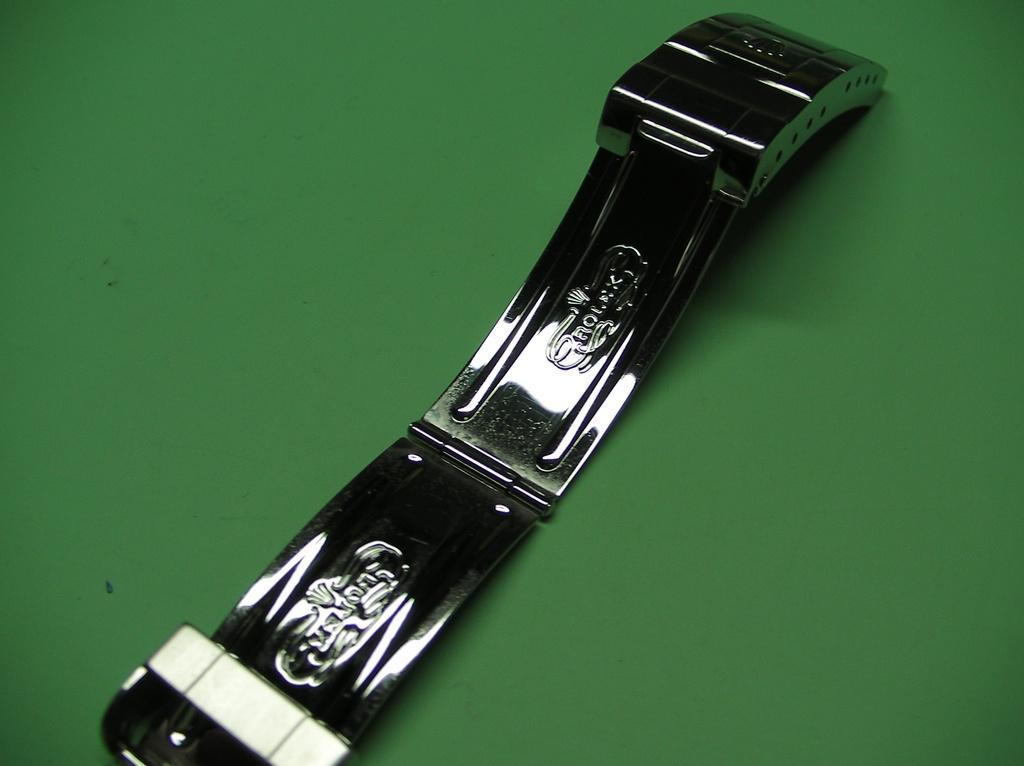Could you give a brief overview of what you see in this image? In this image there is a metal object on the surface which is in green color. There is some text carved on the metal object. 